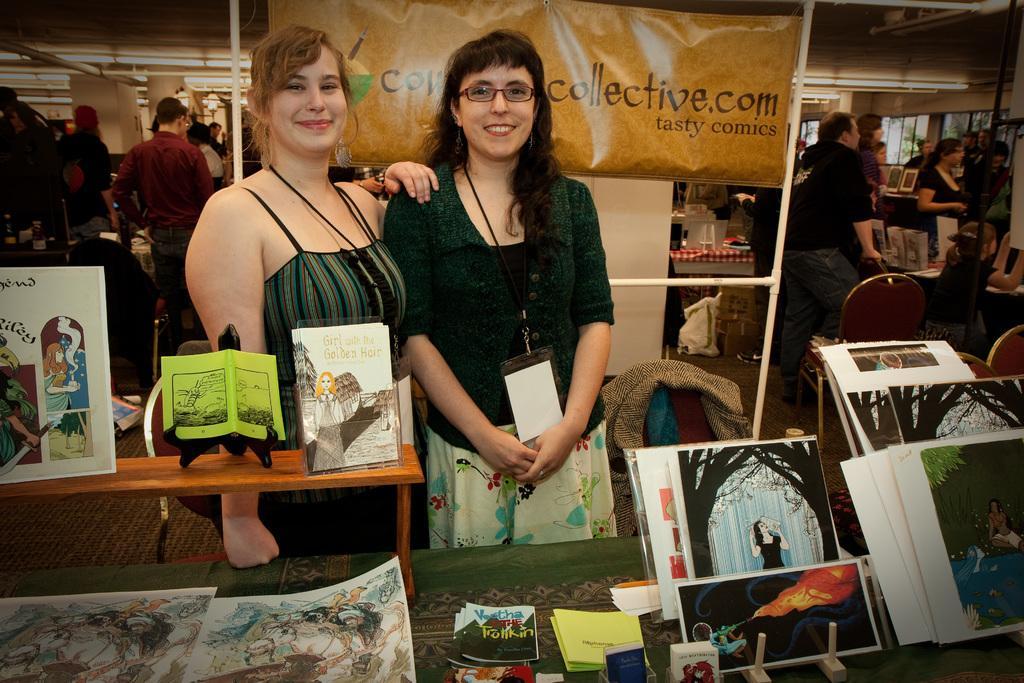How would you summarize this image in a sentence or two? In this picture there are two women standing near the table and there are photographs placed on top of it. In the background we also observe few people near the tables. 